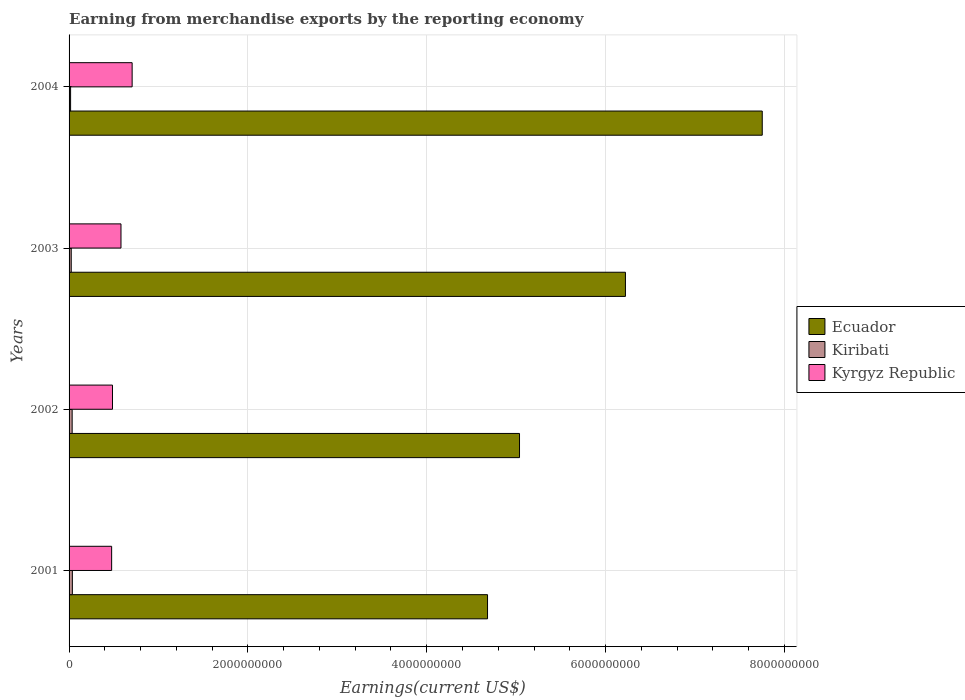Are the number of bars per tick equal to the number of legend labels?
Offer a terse response. Yes. How many bars are there on the 3rd tick from the top?
Provide a short and direct response. 3. What is the label of the 1st group of bars from the top?
Provide a succinct answer. 2004. In how many cases, is the number of bars for a given year not equal to the number of legend labels?
Provide a short and direct response. 0. What is the amount earned from merchandise exports in Kiribati in 2003?
Offer a very short reply. 2.42e+07. Across all years, what is the maximum amount earned from merchandise exports in Kyrgyz Republic?
Offer a very short reply. 7.05e+08. Across all years, what is the minimum amount earned from merchandise exports in Kyrgyz Republic?
Ensure brevity in your answer.  4.76e+08. What is the total amount earned from merchandise exports in Ecuador in the graph?
Provide a short and direct response. 2.37e+1. What is the difference between the amount earned from merchandise exports in Ecuador in 2003 and that in 2004?
Your answer should be compact. -1.53e+09. What is the difference between the amount earned from merchandise exports in Kiribati in 2001 and the amount earned from merchandise exports in Kyrgyz Republic in 2003?
Your answer should be compact. -5.44e+08. What is the average amount earned from merchandise exports in Kyrgyz Republic per year?
Offer a very short reply. 5.62e+08. In the year 2003, what is the difference between the amount earned from merchandise exports in Kyrgyz Republic and amount earned from merchandise exports in Kiribati?
Your response must be concise. 5.56e+08. In how many years, is the amount earned from merchandise exports in Kyrgyz Republic greater than 6800000000 US$?
Your answer should be very brief. 0. What is the ratio of the amount earned from merchandise exports in Kiribati in 2002 to that in 2004?
Provide a short and direct response. 2.03. Is the difference between the amount earned from merchandise exports in Kyrgyz Republic in 2001 and 2004 greater than the difference between the amount earned from merchandise exports in Kiribati in 2001 and 2004?
Make the answer very short. No. What is the difference between the highest and the second highest amount earned from merchandise exports in Ecuador?
Offer a terse response. 1.53e+09. What is the difference between the highest and the lowest amount earned from merchandise exports in Kyrgyz Republic?
Ensure brevity in your answer.  2.29e+08. In how many years, is the amount earned from merchandise exports in Kiribati greater than the average amount earned from merchandise exports in Kiribati taken over all years?
Give a very brief answer. 2. What does the 2nd bar from the top in 2004 represents?
Offer a very short reply. Kiribati. What does the 2nd bar from the bottom in 2004 represents?
Offer a terse response. Kiribati. Is it the case that in every year, the sum of the amount earned from merchandise exports in Kiribati and amount earned from merchandise exports in Ecuador is greater than the amount earned from merchandise exports in Kyrgyz Republic?
Ensure brevity in your answer.  Yes. How many bars are there?
Your answer should be compact. 12. How many years are there in the graph?
Give a very brief answer. 4. What is the difference between two consecutive major ticks on the X-axis?
Offer a very short reply. 2.00e+09. Where does the legend appear in the graph?
Offer a terse response. Center right. How many legend labels are there?
Keep it short and to the point. 3. What is the title of the graph?
Keep it short and to the point. Earning from merchandise exports by the reporting economy. Does "Sweden" appear as one of the legend labels in the graph?
Offer a very short reply. No. What is the label or title of the X-axis?
Your answer should be very brief. Earnings(current US$). What is the Earnings(current US$) in Ecuador in 2001?
Offer a terse response. 4.68e+09. What is the Earnings(current US$) in Kiribati in 2001?
Offer a very short reply. 3.68e+07. What is the Earnings(current US$) in Kyrgyz Republic in 2001?
Your response must be concise. 4.76e+08. What is the Earnings(current US$) of Ecuador in 2002?
Offer a terse response. 5.04e+09. What is the Earnings(current US$) in Kiribati in 2002?
Your response must be concise. 3.46e+07. What is the Earnings(current US$) of Kyrgyz Republic in 2002?
Offer a terse response. 4.86e+08. What is the Earnings(current US$) of Ecuador in 2003?
Make the answer very short. 6.22e+09. What is the Earnings(current US$) in Kiribati in 2003?
Your response must be concise. 2.42e+07. What is the Earnings(current US$) in Kyrgyz Republic in 2003?
Make the answer very short. 5.81e+08. What is the Earnings(current US$) of Ecuador in 2004?
Provide a succinct answer. 7.75e+09. What is the Earnings(current US$) of Kiribati in 2004?
Your answer should be very brief. 1.71e+07. What is the Earnings(current US$) of Kyrgyz Republic in 2004?
Your answer should be compact. 7.05e+08. Across all years, what is the maximum Earnings(current US$) of Ecuador?
Give a very brief answer. 7.75e+09. Across all years, what is the maximum Earnings(current US$) in Kiribati?
Provide a short and direct response. 3.68e+07. Across all years, what is the maximum Earnings(current US$) of Kyrgyz Republic?
Your answer should be compact. 7.05e+08. Across all years, what is the minimum Earnings(current US$) in Ecuador?
Provide a short and direct response. 4.68e+09. Across all years, what is the minimum Earnings(current US$) of Kiribati?
Your answer should be compact. 1.71e+07. Across all years, what is the minimum Earnings(current US$) of Kyrgyz Republic?
Offer a very short reply. 4.76e+08. What is the total Earnings(current US$) in Ecuador in the graph?
Your response must be concise. 2.37e+1. What is the total Earnings(current US$) in Kiribati in the graph?
Your answer should be very brief. 1.13e+08. What is the total Earnings(current US$) in Kyrgyz Republic in the graph?
Offer a very short reply. 2.25e+09. What is the difference between the Earnings(current US$) in Ecuador in 2001 and that in 2002?
Give a very brief answer. -3.58e+08. What is the difference between the Earnings(current US$) in Kiribati in 2001 and that in 2002?
Make the answer very short. 2.25e+06. What is the difference between the Earnings(current US$) in Kyrgyz Republic in 2001 and that in 2002?
Give a very brief answer. -9.45e+06. What is the difference between the Earnings(current US$) of Ecuador in 2001 and that in 2003?
Give a very brief answer. -1.54e+09. What is the difference between the Earnings(current US$) of Kiribati in 2001 and that in 2003?
Keep it short and to the point. 1.26e+07. What is the difference between the Earnings(current US$) in Kyrgyz Republic in 2001 and that in 2003?
Your answer should be compact. -1.05e+08. What is the difference between the Earnings(current US$) of Ecuador in 2001 and that in 2004?
Offer a terse response. -3.07e+09. What is the difference between the Earnings(current US$) in Kiribati in 2001 and that in 2004?
Give a very brief answer. 1.98e+07. What is the difference between the Earnings(current US$) of Kyrgyz Republic in 2001 and that in 2004?
Provide a succinct answer. -2.29e+08. What is the difference between the Earnings(current US$) in Ecuador in 2002 and that in 2003?
Ensure brevity in your answer.  -1.18e+09. What is the difference between the Earnings(current US$) in Kiribati in 2002 and that in 2003?
Provide a short and direct response. 1.04e+07. What is the difference between the Earnings(current US$) in Kyrgyz Republic in 2002 and that in 2003?
Your answer should be very brief. -9.52e+07. What is the difference between the Earnings(current US$) in Ecuador in 2002 and that in 2004?
Keep it short and to the point. -2.71e+09. What is the difference between the Earnings(current US$) of Kiribati in 2002 and that in 2004?
Keep it short and to the point. 1.75e+07. What is the difference between the Earnings(current US$) of Kyrgyz Republic in 2002 and that in 2004?
Make the answer very short. -2.20e+08. What is the difference between the Earnings(current US$) of Ecuador in 2003 and that in 2004?
Ensure brevity in your answer.  -1.53e+09. What is the difference between the Earnings(current US$) in Kiribati in 2003 and that in 2004?
Offer a terse response. 7.16e+06. What is the difference between the Earnings(current US$) in Kyrgyz Republic in 2003 and that in 2004?
Offer a very short reply. -1.25e+08. What is the difference between the Earnings(current US$) in Ecuador in 2001 and the Earnings(current US$) in Kiribati in 2002?
Ensure brevity in your answer.  4.65e+09. What is the difference between the Earnings(current US$) of Ecuador in 2001 and the Earnings(current US$) of Kyrgyz Republic in 2002?
Offer a terse response. 4.19e+09. What is the difference between the Earnings(current US$) of Kiribati in 2001 and the Earnings(current US$) of Kyrgyz Republic in 2002?
Make the answer very short. -4.49e+08. What is the difference between the Earnings(current US$) in Ecuador in 2001 and the Earnings(current US$) in Kiribati in 2003?
Your response must be concise. 4.66e+09. What is the difference between the Earnings(current US$) of Ecuador in 2001 and the Earnings(current US$) of Kyrgyz Republic in 2003?
Your answer should be very brief. 4.10e+09. What is the difference between the Earnings(current US$) in Kiribati in 2001 and the Earnings(current US$) in Kyrgyz Republic in 2003?
Offer a terse response. -5.44e+08. What is the difference between the Earnings(current US$) of Ecuador in 2001 and the Earnings(current US$) of Kiribati in 2004?
Make the answer very short. 4.66e+09. What is the difference between the Earnings(current US$) in Ecuador in 2001 and the Earnings(current US$) in Kyrgyz Republic in 2004?
Offer a very short reply. 3.97e+09. What is the difference between the Earnings(current US$) in Kiribati in 2001 and the Earnings(current US$) in Kyrgyz Republic in 2004?
Make the answer very short. -6.69e+08. What is the difference between the Earnings(current US$) of Ecuador in 2002 and the Earnings(current US$) of Kiribati in 2003?
Offer a terse response. 5.01e+09. What is the difference between the Earnings(current US$) of Ecuador in 2002 and the Earnings(current US$) of Kyrgyz Republic in 2003?
Keep it short and to the point. 4.46e+09. What is the difference between the Earnings(current US$) of Kiribati in 2002 and the Earnings(current US$) of Kyrgyz Republic in 2003?
Make the answer very short. -5.46e+08. What is the difference between the Earnings(current US$) in Ecuador in 2002 and the Earnings(current US$) in Kiribati in 2004?
Your answer should be compact. 5.02e+09. What is the difference between the Earnings(current US$) of Ecuador in 2002 and the Earnings(current US$) of Kyrgyz Republic in 2004?
Your answer should be compact. 4.33e+09. What is the difference between the Earnings(current US$) in Kiribati in 2002 and the Earnings(current US$) in Kyrgyz Republic in 2004?
Offer a very short reply. -6.71e+08. What is the difference between the Earnings(current US$) of Ecuador in 2003 and the Earnings(current US$) of Kiribati in 2004?
Your response must be concise. 6.21e+09. What is the difference between the Earnings(current US$) of Ecuador in 2003 and the Earnings(current US$) of Kyrgyz Republic in 2004?
Provide a succinct answer. 5.52e+09. What is the difference between the Earnings(current US$) of Kiribati in 2003 and the Earnings(current US$) of Kyrgyz Republic in 2004?
Ensure brevity in your answer.  -6.81e+08. What is the average Earnings(current US$) in Ecuador per year?
Provide a short and direct response. 5.92e+09. What is the average Earnings(current US$) of Kiribati per year?
Offer a terse response. 2.82e+07. What is the average Earnings(current US$) in Kyrgyz Republic per year?
Keep it short and to the point. 5.62e+08. In the year 2001, what is the difference between the Earnings(current US$) in Ecuador and Earnings(current US$) in Kiribati?
Provide a short and direct response. 4.64e+09. In the year 2001, what is the difference between the Earnings(current US$) of Ecuador and Earnings(current US$) of Kyrgyz Republic?
Your answer should be very brief. 4.20e+09. In the year 2001, what is the difference between the Earnings(current US$) in Kiribati and Earnings(current US$) in Kyrgyz Republic?
Your response must be concise. -4.39e+08. In the year 2002, what is the difference between the Earnings(current US$) in Ecuador and Earnings(current US$) in Kiribati?
Offer a very short reply. 5.00e+09. In the year 2002, what is the difference between the Earnings(current US$) in Ecuador and Earnings(current US$) in Kyrgyz Republic?
Provide a succinct answer. 4.55e+09. In the year 2002, what is the difference between the Earnings(current US$) in Kiribati and Earnings(current US$) in Kyrgyz Republic?
Offer a terse response. -4.51e+08. In the year 2003, what is the difference between the Earnings(current US$) in Ecuador and Earnings(current US$) in Kiribati?
Provide a short and direct response. 6.20e+09. In the year 2003, what is the difference between the Earnings(current US$) in Ecuador and Earnings(current US$) in Kyrgyz Republic?
Give a very brief answer. 5.64e+09. In the year 2003, what is the difference between the Earnings(current US$) of Kiribati and Earnings(current US$) of Kyrgyz Republic?
Offer a terse response. -5.56e+08. In the year 2004, what is the difference between the Earnings(current US$) of Ecuador and Earnings(current US$) of Kiribati?
Provide a short and direct response. 7.74e+09. In the year 2004, what is the difference between the Earnings(current US$) in Ecuador and Earnings(current US$) in Kyrgyz Republic?
Ensure brevity in your answer.  7.05e+09. In the year 2004, what is the difference between the Earnings(current US$) of Kiribati and Earnings(current US$) of Kyrgyz Republic?
Ensure brevity in your answer.  -6.88e+08. What is the ratio of the Earnings(current US$) of Ecuador in 2001 to that in 2002?
Provide a short and direct response. 0.93. What is the ratio of the Earnings(current US$) of Kiribati in 2001 to that in 2002?
Make the answer very short. 1.06. What is the ratio of the Earnings(current US$) of Kyrgyz Republic in 2001 to that in 2002?
Provide a short and direct response. 0.98. What is the ratio of the Earnings(current US$) of Ecuador in 2001 to that in 2003?
Give a very brief answer. 0.75. What is the ratio of the Earnings(current US$) of Kiribati in 2001 to that in 2003?
Offer a very short reply. 1.52. What is the ratio of the Earnings(current US$) of Kyrgyz Republic in 2001 to that in 2003?
Provide a short and direct response. 0.82. What is the ratio of the Earnings(current US$) of Ecuador in 2001 to that in 2004?
Ensure brevity in your answer.  0.6. What is the ratio of the Earnings(current US$) in Kiribati in 2001 to that in 2004?
Offer a terse response. 2.16. What is the ratio of the Earnings(current US$) of Kyrgyz Republic in 2001 to that in 2004?
Provide a short and direct response. 0.67. What is the ratio of the Earnings(current US$) in Ecuador in 2002 to that in 2003?
Ensure brevity in your answer.  0.81. What is the ratio of the Earnings(current US$) of Kiribati in 2002 to that in 2003?
Keep it short and to the point. 1.43. What is the ratio of the Earnings(current US$) in Kyrgyz Republic in 2002 to that in 2003?
Offer a very short reply. 0.84. What is the ratio of the Earnings(current US$) of Ecuador in 2002 to that in 2004?
Ensure brevity in your answer.  0.65. What is the ratio of the Earnings(current US$) in Kiribati in 2002 to that in 2004?
Your answer should be very brief. 2.03. What is the ratio of the Earnings(current US$) of Kyrgyz Republic in 2002 to that in 2004?
Make the answer very short. 0.69. What is the ratio of the Earnings(current US$) of Ecuador in 2003 to that in 2004?
Keep it short and to the point. 0.8. What is the ratio of the Earnings(current US$) of Kiribati in 2003 to that in 2004?
Offer a terse response. 1.42. What is the ratio of the Earnings(current US$) in Kyrgyz Republic in 2003 to that in 2004?
Your answer should be very brief. 0.82. What is the difference between the highest and the second highest Earnings(current US$) of Ecuador?
Keep it short and to the point. 1.53e+09. What is the difference between the highest and the second highest Earnings(current US$) in Kiribati?
Provide a short and direct response. 2.25e+06. What is the difference between the highest and the second highest Earnings(current US$) of Kyrgyz Republic?
Your response must be concise. 1.25e+08. What is the difference between the highest and the lowest Earnings(current US$) of Ecuador?
Provide a short and direct response. 3.07e+09. What is the difference between the highest and the lowest Earnings(current US$) of Kiribati?
Ensure brevity in your answer.  1.98e+07. What is the difference between the highest and the lowest Earnings(current US$) in Kyrgyz Republic?
Give a very brief answer. 2.29e+08. 